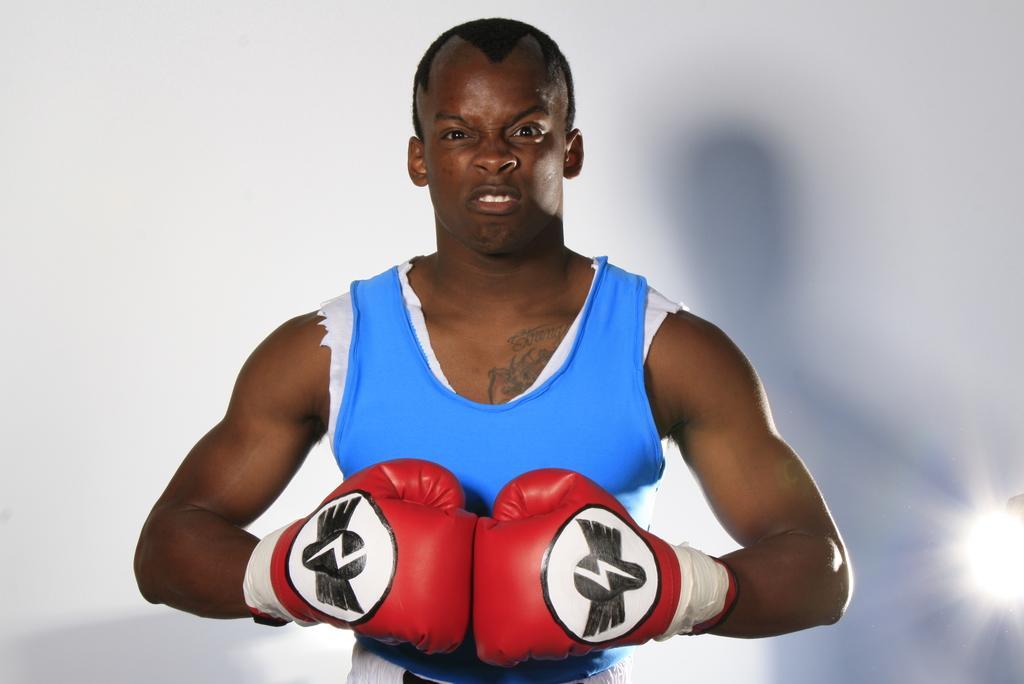How would you summarize this image in a sentence or two? In this image, we can see a person wearing boxing gloves. We can also see the white background. We can also see a light on the right. 